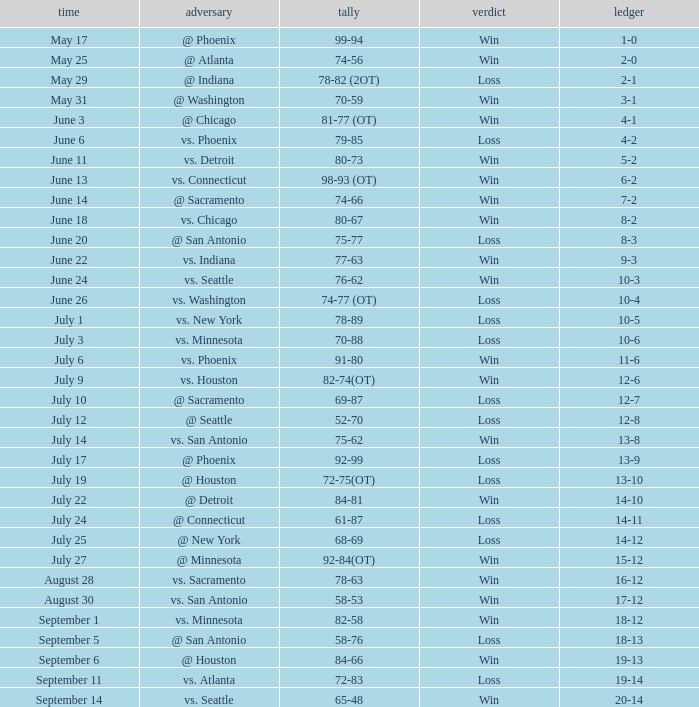What is the Opponent of the game with a Score of 74-66? @ Sacramento. 